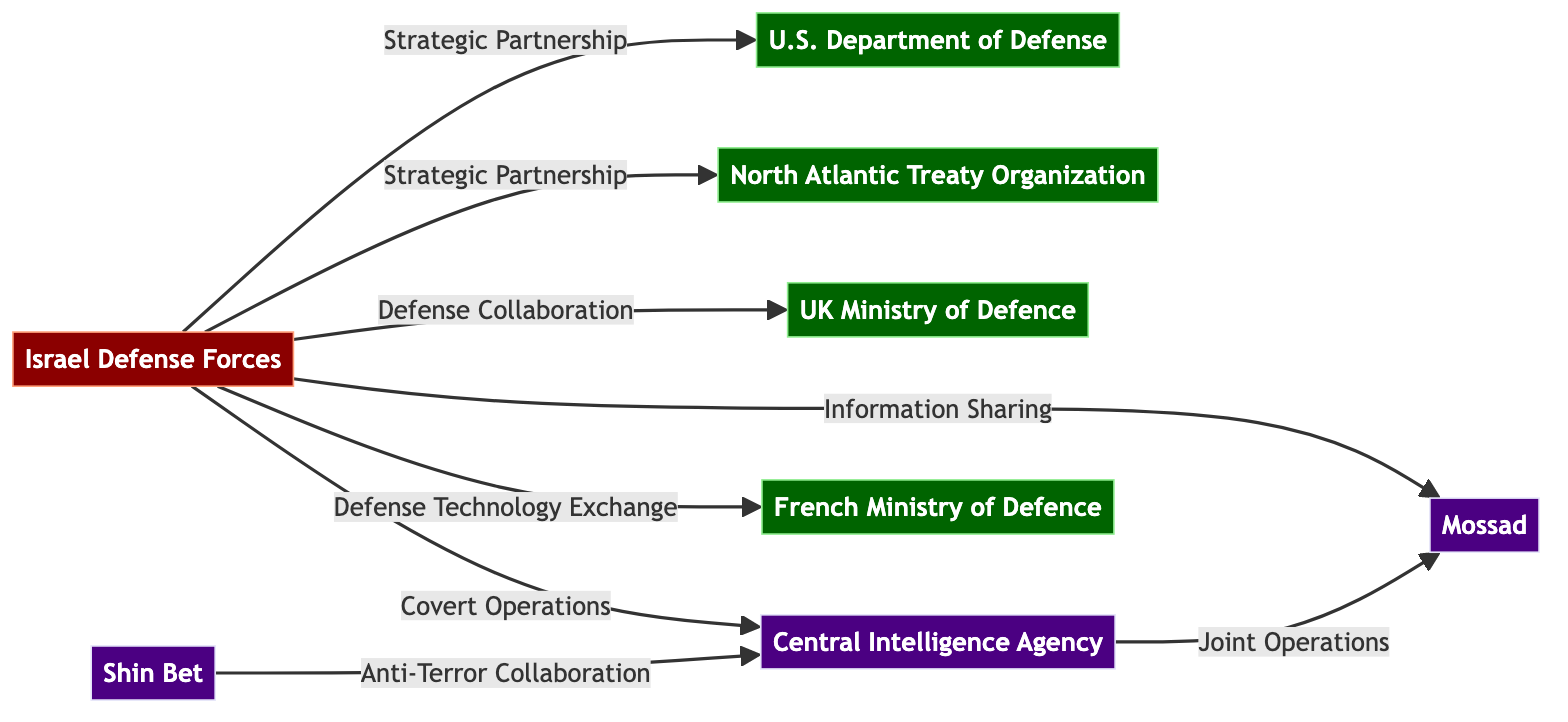What is the total number of nodes in the diagram? The diagram contains eight nodes: IDF, US Department of Defense, NATO, UK Ministry of Defence, Mossad, CIA, Shin Bet, and French Ministry of Defence. Counting these gives us a total of eight nodes.
Answer: 8 What type of relationship does IDF have with the CIA? The relationship between IDF and CIA is labeled as "Covert Operations," which indicates that they collaborate on undisclosed military actions.
Answer: Covert Operations Which organization is connected to the most nodes in the diagram? By analyzing the connections, it can be seen that IDF has relationships with five other nodes (US DoD, NATO, UK Mod, Mossad, and French Mod), making it the organization connected to the most nodes.
Answer: IDF How many edges connect the IDF to defense organizations? The IDF has three direct connections to defense organizations: US DoD, NATO, and UK Mod. Thus, the total number of edges connecting IDF to defense organizations is three.
Answer: 3 What type of collaboration is seen between Shin Bet and CIA? The diagram shows that Shin Bet collaborates with CIA through "Anti-Terror Collaboration." This indicates a partnership focused on combating terrorism.
Answer: Anti-Terror Collaboration Which two organizations have a Joint Operations relationship? The two organizations engaged in a Joint Operations relationship are CIA and Mossad, indicating their cooperation on specific missions.
Answer: CIA, Mossad What is the relationship labeling between IDF and French Ministry of Defence? The nature of the relationship between IDF and the French Ministry of Defence is defined as "Defense Technology Exchange," reflecting their collaboration on military technologies.
Answer: Defense Technology Exchange How many intelligence organizations are represented in the diagram? There are three intelligence organizations in the diagram: Mossad, CIA, and Shin Bet. Adding these gives a total of three intelligence organizations.
Answer: 3 